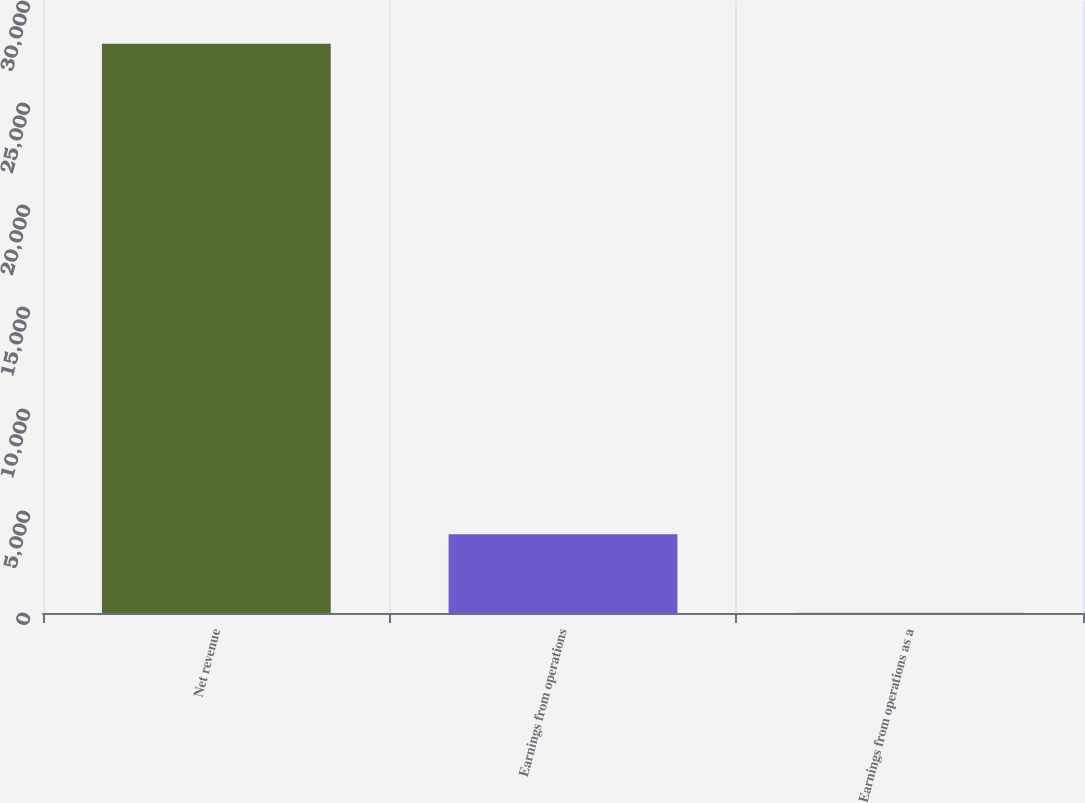Convert chart. <chart><loc_0><loc_0><loc_500><loc_500><bar_chart><fcel>Net revenue<fcel>Earnings from operations<fcel>Earnings from operations as a<nl><fcel>27907<fcel>3862<fcel>13.8<nl></chart> 